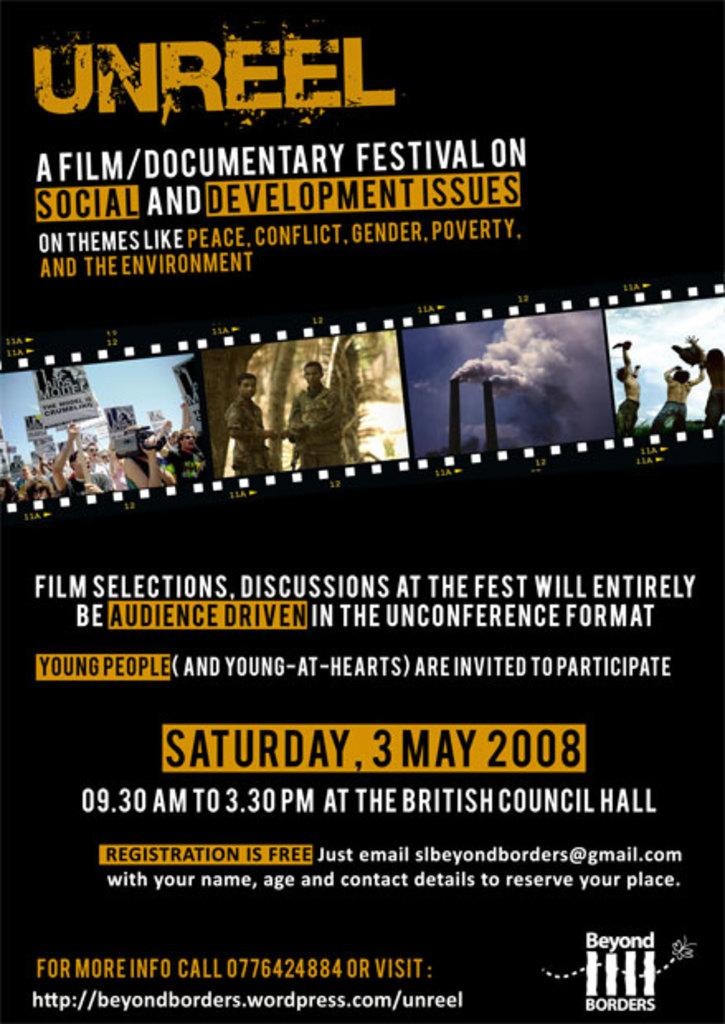Provide a one-sentence caption for the provided image. The Unreel Film and Documentary Festival is going to take place on Saturday, May 3rd, 2008. 